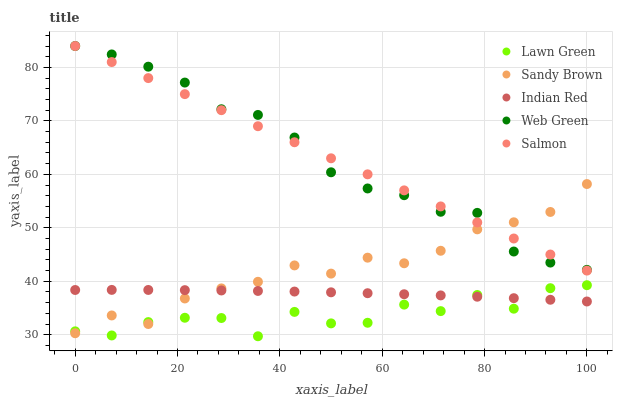Does Lawn Green have the minimum area under the curve?
Answer yes or no. Yes. Does Salmon have the maximum area under the curve?
Answer yes or no. Yes. Does Sandy Brown have the minimum area under the curve?
Answer yes or no. No. Does Sandy Brown have the maximum area under the curve?
Answer yes or no. No. Is Salmon the smoothest?
Answer yes or no. Yes. Is Lawn Green the roughest?
Answer yes or no. Yes. Is Sandy Brown the smoothest?
Answer yes or no. No. Is Sandy Brown the roughest?
Answer yes or no. No. Does Lawn Green have the lowest value?
Answer yes or no. Yes. Does Sandy Brown have the lowest value?
Answer yes or no. No. Does Salmon have the highest value?
Answer yes or no. Yes. Does Sandy Brown have the highest value?
Answer yes or no. No. Is Indian Red less than Salmon?
Answer yes or no. Yes. Is Web Green greater than Indian Red?
Answer yes or no. Yes. Does Indian Red intersect Lawn Green?
Answer yes or no. Yes. Is Indian Red less than Lawn Green?
Answer yes or no. No. Is Indian Red greater than Lawn Green?
Answer yes or no. No. Does Indian Red intersect Salmon?
Answer yes or no. No. 